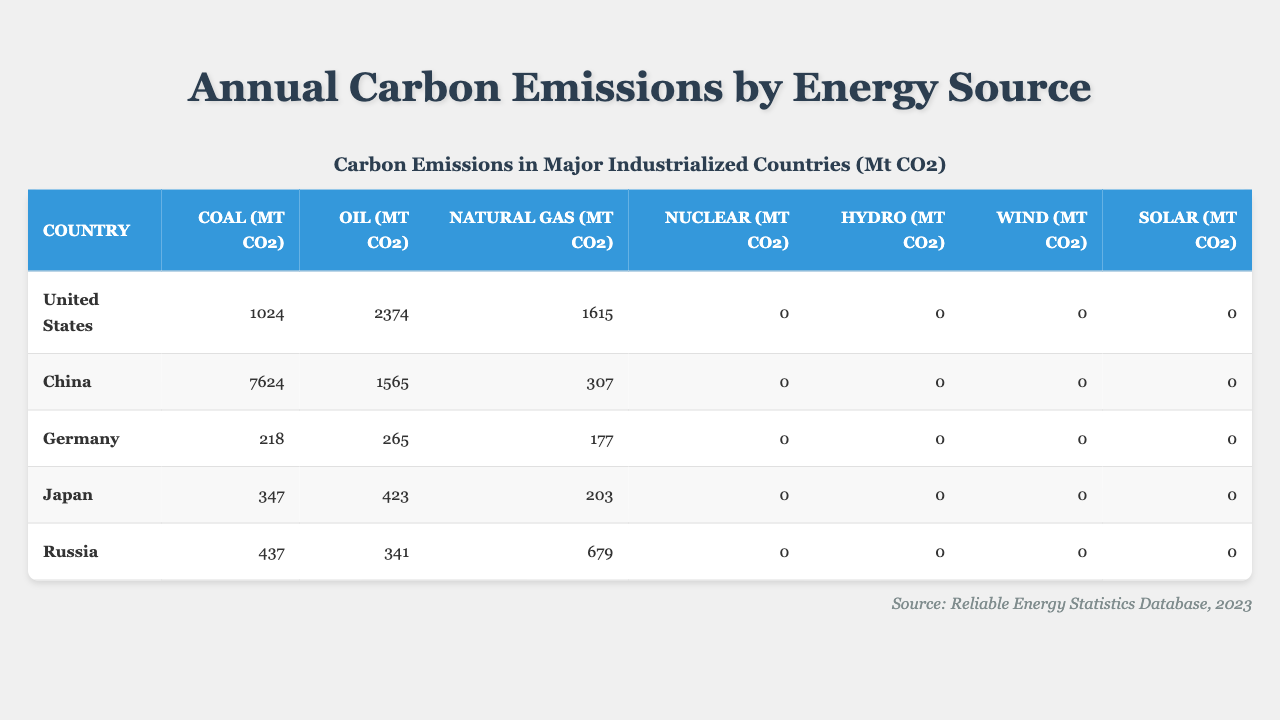What country has the highest carbon emissions from coal? By examining the "Coal (Mt CO2)" column, we can see that China has the highest emissions, which is 7624 Mt CO2.
Answer: China What are the total carbon emissions from oil across all countries? Adding the oil emissions: 2374 (US) + 1565 (China) + 265 (Germany) + 423 (Japan) + 341 (Russia) = 4938 Mt CO2.
Answer: 4938 Mt CO2 Which country has the lowest carbon emissions from natural gas? Looking at the "Natural Gas (Mt CO2)" column, we find that China has the lowest emissions, which is 307 Mt CO2.
Answer: China Is there any country that has zero carbon emissions from nuclear, hydro, wind, or solar? Reviewing the respective columns, we can confirm that all listed countries have zero emissions for nuclear, hydro, wind, and solar sources.
Answer: Yes What is the total carbon emissions from coal for the United States and Japan? Summing the coal emissions for these two countries: 1024 (US) + 347 (Japan) = 1371 Mt CO2.
Answer: 1371 Mt CO2 Which energy source contributes the most to carbon emissions for Japan? Analyzing the data, oil emissions (423 Mt CO2) are higher than coal (347 Mt CO2) and natural gas (203 Mt CO2), making oil the highest contributor for Japan.
Answer: Oil How does the total carbon emissions from coal in Germany compare to that of Russia? For Germany, coal emissions are 218 Mt CO2, while for Russia, they are 437 Mt CO2. This shows that Russia's emissions from coal are almost double that of Germany.
Answer: Russia's coal emissions are higher What percentage of the total carbon emissions from coal is attributed to the United States? Total coal emissions are 1024 (US) + 7624 (China) + 218 (Germany) + 347 (Japan) + 437 (Russia) = 9228 Mt CO2. The percentage for the US is (1024 / 9228) * 100 = 11.08%.
Answer: 11.08% 